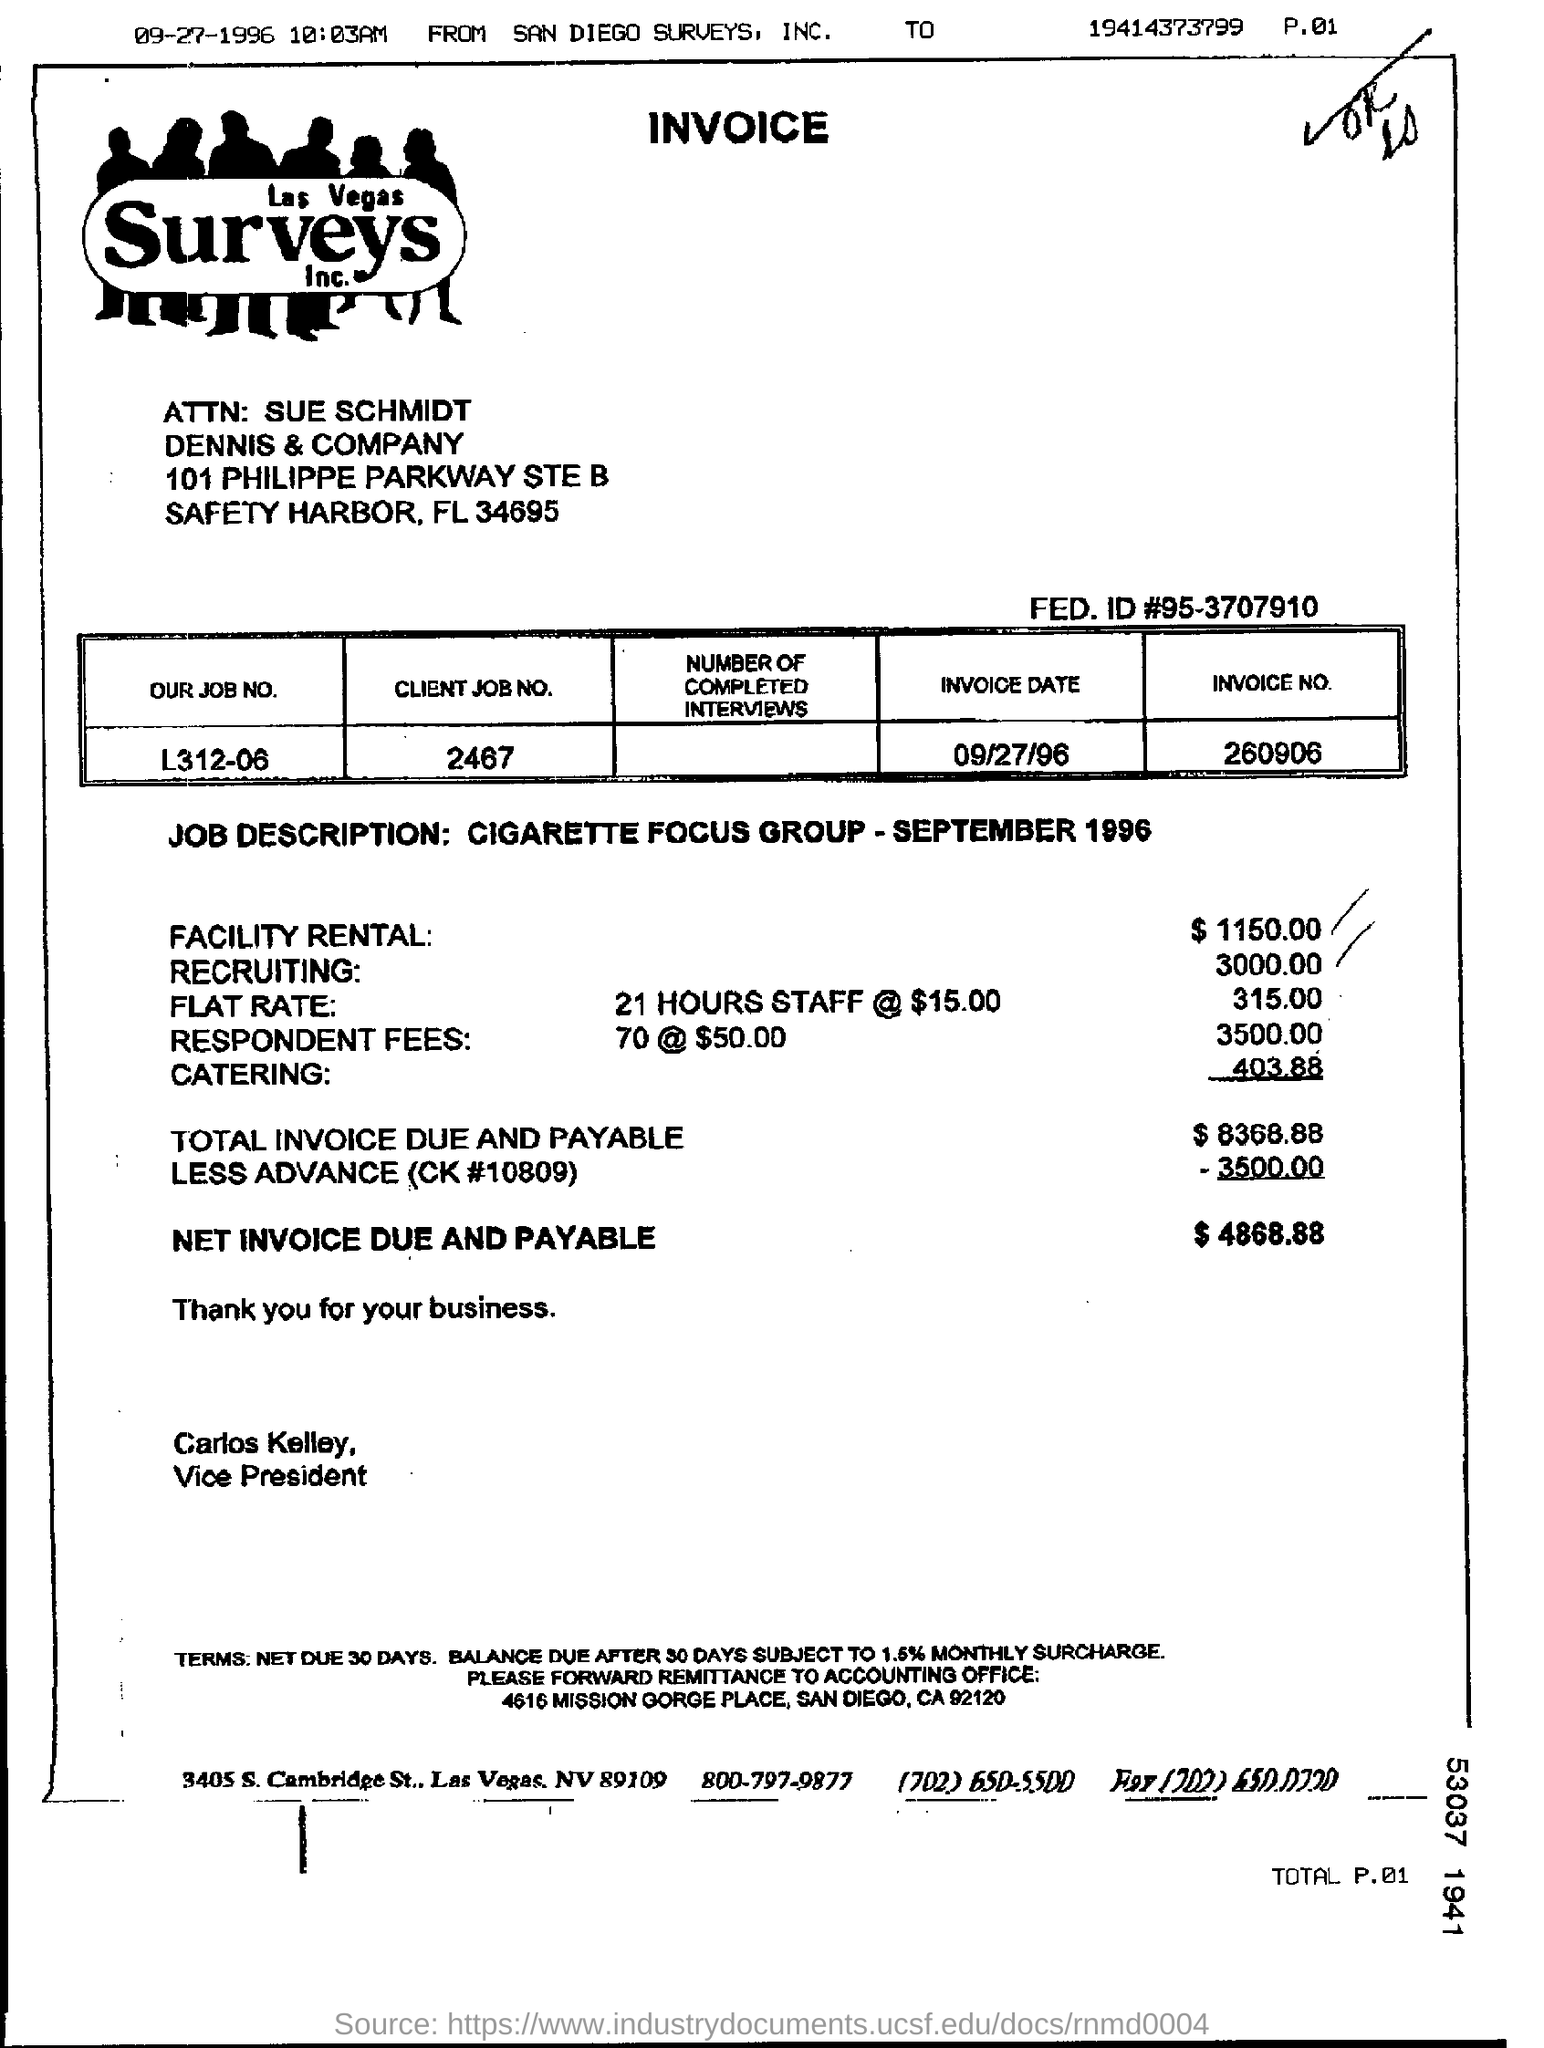What is the Invoice No mentioned in this document?
Give a very brief answer. 260906. What is the invoice date as per the document?
Give a very brief answer. 09/27/96. What is the amount of Net Invoice Due and Payable?
Give a very brief answer. $ 4868.88. How much is the Facility Rental cost?
Keep it short and to the point. $ 1150.00. What is the Client Job No. mentioned in the Invoice?
Your answer should be compact. 2467. 